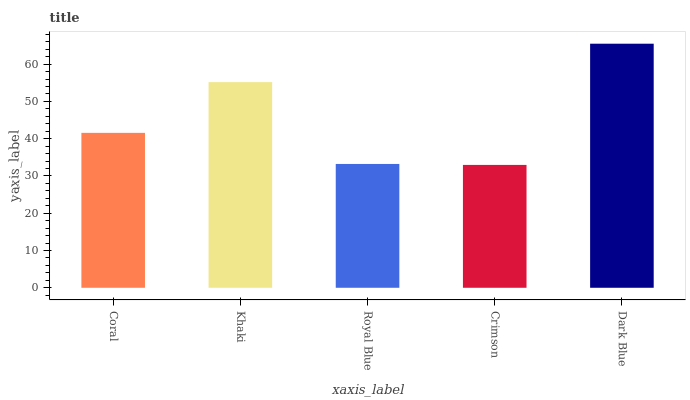Is Crimson the minimum?
Answer yes or no. Yes. Is Dark Blue the maximum?
Answer yes or no. Yes. Is Khaki the minimum?
Answer yes or no. No. Is Khaki the maximum?
Answer yes or no. No. Is Khaki greater than Coral?
Answer yes or no. Yes. Is Coral less than Khaki?
Answer yes or no. Yes. Is Coral greater than Khaki?
Answer yes or no. No. Is Khaki less than Coral?
Answer yes or no. No. Is Coral the high median?
Answer yes or no. Yes. Is Coral the low median?
Answer yes or no. Yes. Is Royal Blue the high median?
Answer yes or no. No. Is Khaki the low median?
Answer yes or no. No. 